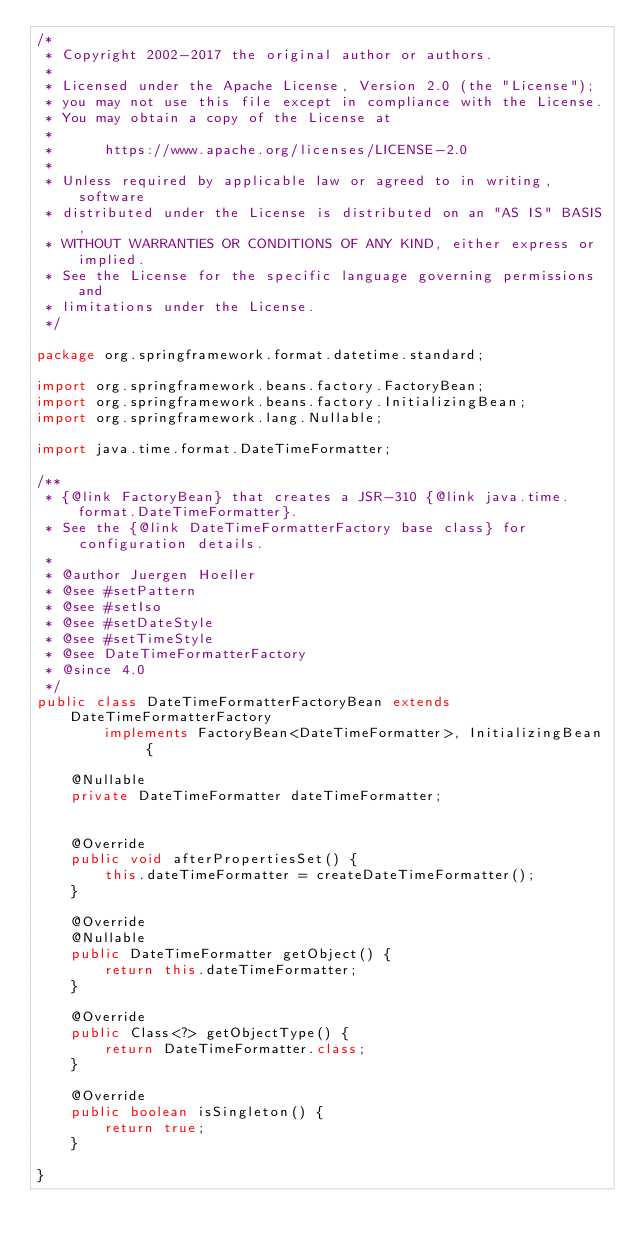Convert code to text. <code><loc_0><loc_0><loc_500><loc_500><_Java_>/*
 * Copyright 2002-2017 the original author or authors.
 *
 * Licensed under the Apache License, Version 2.0 (the "License");
 * you may not use this file except in compliance with the License.
 * You may obtain a copy of the License at
 *
 *      https://www.apache.org/licenses/LICENSE-2.0
 *
 * Unless required by applicable law or agreed to in writing, software
 * distributed under the License is distributed on an "AS IS" BASIS,
 * WITHOUT WARRANTIES OR CONDITIONS OF ANY KIND, either express or implied.
 * See the License for the specific language governing permissions and
 * limitations under the License.
 */

package org.springframework.format.datetime.standard;

import org.springframework.beans.factory.FactoryBean;
import org.springframework.beans.factory.InitializingBean;
import org.springframework.lang.Nullable;

import java.time.format.DateTimeFormatter;

/**
 * {@link FactoryBean} that creates a JSR-310 {@link java.time.format.DateTimeFormatter}.
 * See the {@link DateTimeFormatterFactory base class} for configuration details.
 *
 * @author Juergen Hoeller
 * @see #setPattern
 * @see #setIso
 * @see #setDateStyle
 * @see #setTimeStyle
 * @see DateTimeFormatterFactory
 * @since 4.0
 */
public class DateTimeFormatterFactoryBean extends DateTimeFormatterFactory
        implements FactoryBean<DateTimeFormatter>, InitializingBean {

    @Nullable
    private DateTimeFormatter dateTimeFormatter;


    @Override
    public void afterPropertiesSet() {
        this.dateTimeFormatter = createDateTimeFormatter();
    }

    @Override
    @Nullable
    public DateTimeFormatter getObject() {
        return this.dateTimeFormatter;
    }

    @Override
    public Class<?> getObjectType() {
        return DateTimeFormatter.class;
    }

    @Override
    public boolean isSingleton() {
        return true;
    }

}
</code> 